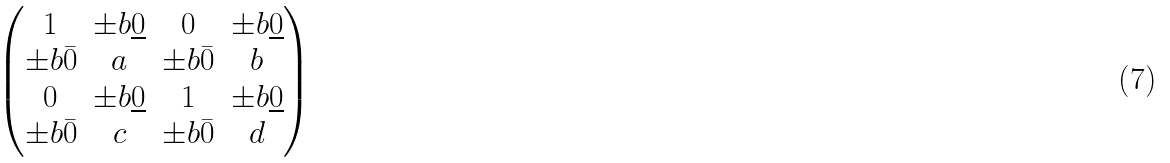Convert formula to latex. <formula><loc_0><loc_0><loc_500><loc_500>\begin{pmatrix} 1 & \pm b { \underline { 0 } } & 0 & \pm b { \underline { 0 } } \\ \pm b { \bar { 0 } } & a & \pm b { \bar { 0 } } & b \\ 0 & \pm b { \underline { 0 } } & 1 & \pm b { \underline { 0 } } \\ \pm b { \bar { 0 } } & c & \pm b { \bar { 0 } } & d \end{pmatrix}</formula> 